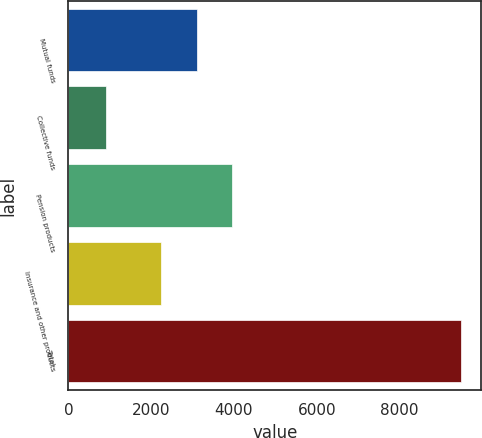Convert chart. <chart><loc_0><loc_0><loc_500><loc_500><bar_chart><fcel>Mutual funds<fcel>Collective funds<fcel>Pension products<fcel>Insurance and other products<fcel>Total<nl><fcel>3102.6<fcel>911<fcel>3961.2<fcel>2244<fcel>9497<nl></chart> 